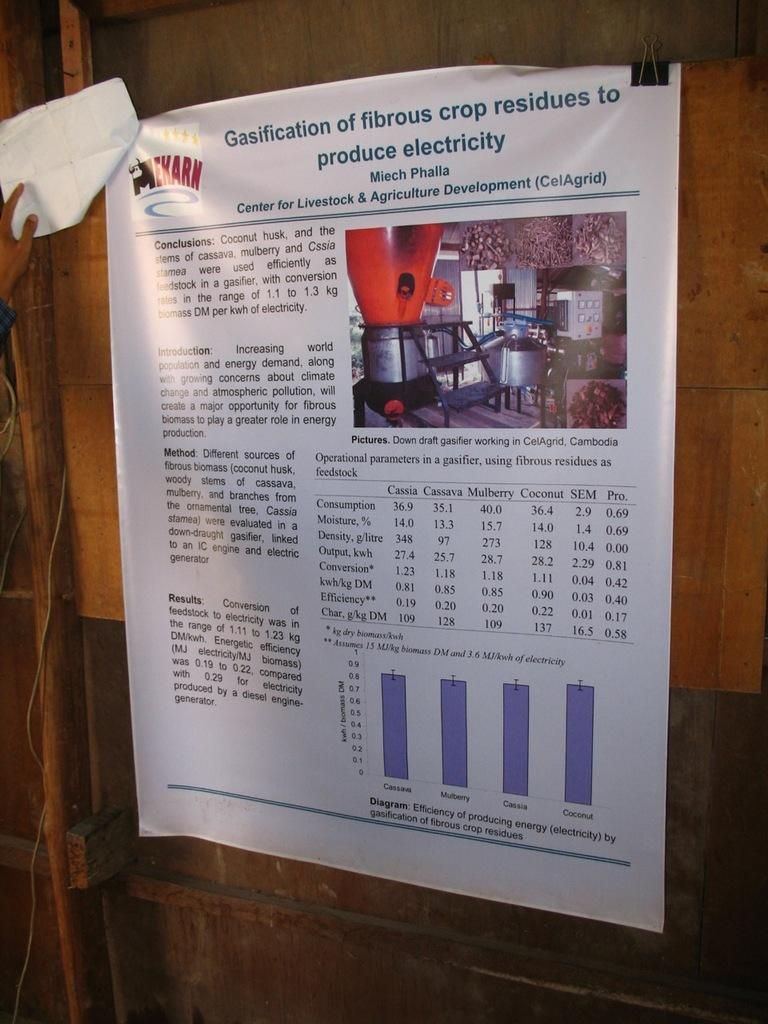<image>
Present a compact description of the photo's key features. Some printed information with a chart from the Center for Livestock & Agriculture Development. 